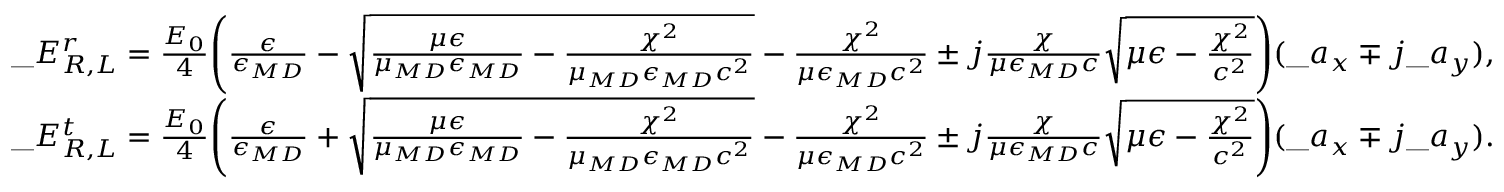<formula> <loc_0><loc_0><loc_500><loc_500>\begin{array} { r l } & { \_ E _ { { \/ R } , { \/ L } } ^ { r } = { \frac { E _ { 0 } } { 4 } } \left ( { \frac { \epsilon } { \epsilon _ { \/ { M D } } } } - \sqrt { { \frac { \mu \epsilon } { \mu _ { \/ { M D } } \epsilon _ { \/ { M D } } } } - { \frac { \chi ^ { 2 } } { \mu _ { \/ { M D } } \epsilon _ { \/ { M D } } c ^ { 2 } } } } - { \frac { \chi ^ { 2 } } { \mu \epsilon _ { \/ { M D } } c ^ { 2 } } } \pm j { \frac { \chi } { \mu \epsilon _ { \/ { M D } } c } } \sqrt { \mu \epsilon - { \frac { \chi ^ { 2 } } { c ^ { 2 } } } } \right ) ( \_ a _ { x } \mp j \_ a _ { y } ) , } \\ & { \_ E _ { { \/ R } , { \/ L } } ^ { t } = { \frac { E _ { 0 } } { 4 } } \left ( { \frac { \epsilon } { \epsilon _ { \/ { M D } } } } + \sqrt { { \frac { \mu \epsilon } { \mu _ { \/ { M D } } \epsilon _ { \/ { M D } } } } - { \frac { \chi ^ { 2 } } { \mu _ { \/ { M D } } \epsilon _ { \/ { M D } } c ^ { 2 } } } } - { \frac { \chi ^ { 2 } } { \mu \epsilon _ { \/ { M D } } c ^ { 2 } } } \pm j { \frac { \chi } { \mu \epsilon _ { \/ { M D } } c } } \sqrt { \mu \epsilon - { \frac { \chi ^ { 2 } } { c ^ { 2 } } } } \right ) ( \_ a _ { x } \mp j \_ a _ { y } ) . } \end{array}</formula> 